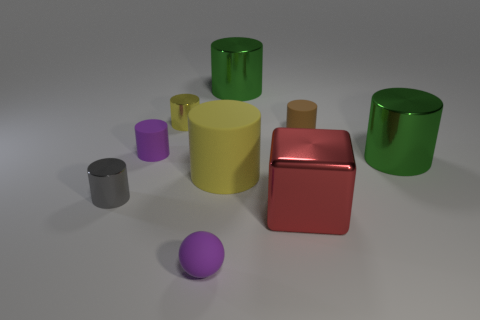The yellow matte thing is what size?
Provide a short and direct response. Large. Is there a cube of the same color as the large matte thing?
Ensure brevity in your answer.  No. What number of large objects are either gray cylinders or cylinders?
Provide a short and direct response. 3. There is a shiny cylinder that is both on the left side of the purple sphere and in front of the brown matte object; how big is it?
Give a very brief answer. Small. There is a small yellow metallic thing; what number of small purple matte cylinders are on the left side of it?
Offer a very short reply. 1. There is a thing that is both on the left side of the big yellow rubber thing and to the right of the tiny yellow metallic thing; what is its shape?
Your answer should be compact. Sphere. What is the material of the tiny object that is the same color as the rubber ball?
Ensure brevity in your answer.  Rubber. How many cylinders are tiny purple objects or big metallic things?
Your answer should be compact. 3. What is the size of the cylinder that is the same color as the tiny sphere?
Ensure brevity in your answer.  Small. Is the number of large red objects to the left of the gray shiny thing less than the number of big matte objects?
Your answer should be very brief. Yes. 